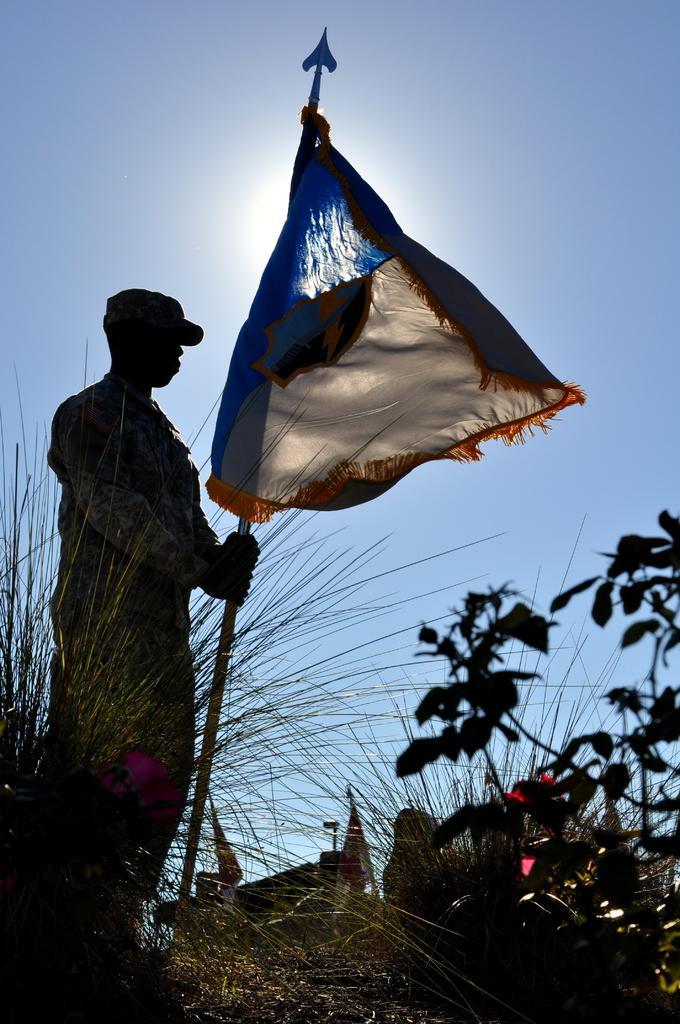How would you summarize this image in a sentence or two? In this picture there is a soldier standing and holding a rod which has a flag attached to it and there are few plants beside him. 